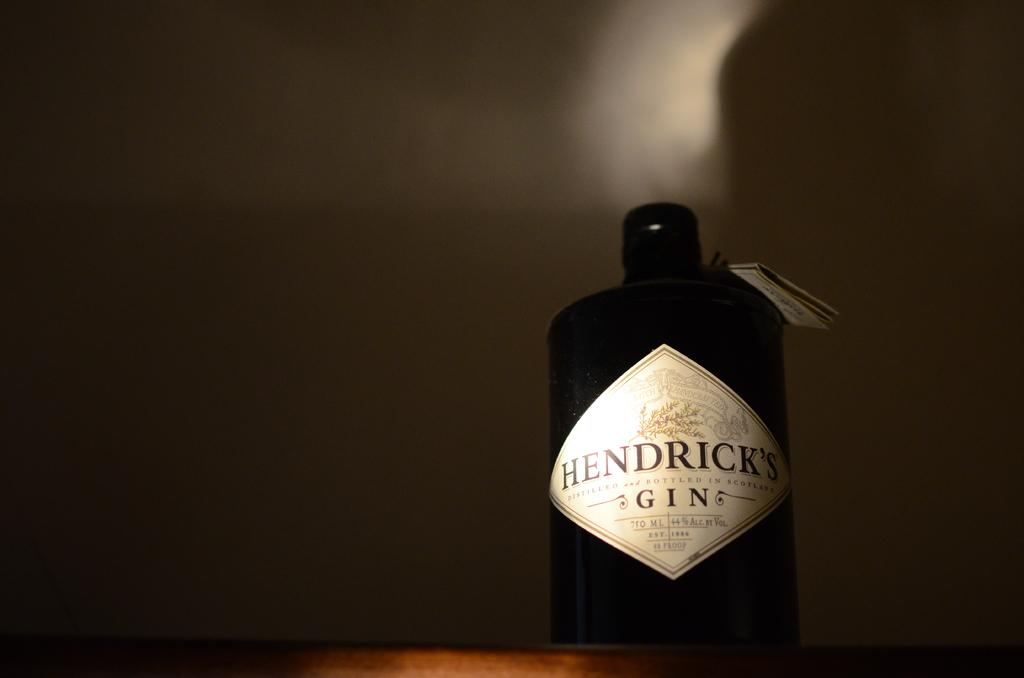Provide a one-sentence caption for the provided image. A 750 ml bottle of Hendrick's gin is 44% alcohol. 